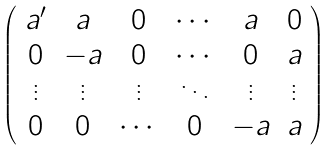<formula> <loc_0><loc_0><loc_500><loc_500>\left ( \begin{array} { c c c c c c } a ^ { \prime } & a & 0 & \cdots & a & 0 \\ 0 & - a & 0 & \cdots & 0 & a \\ \vdots & \vdots & \vdots & \ddots & \vdots & \vdots \\ 0 & 0 & \cdots & 0 & - a & a \end{array} \right )</formula> 